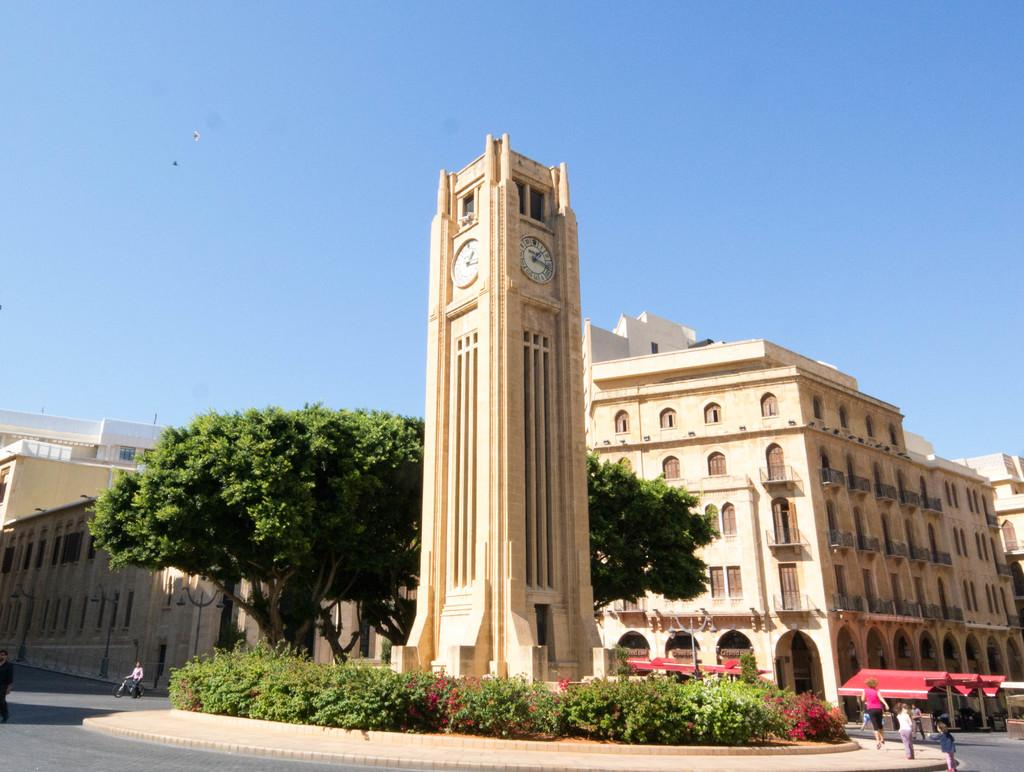<image>
Describe the image concisely. A rolex clock tower sits in the middle of some greenery 